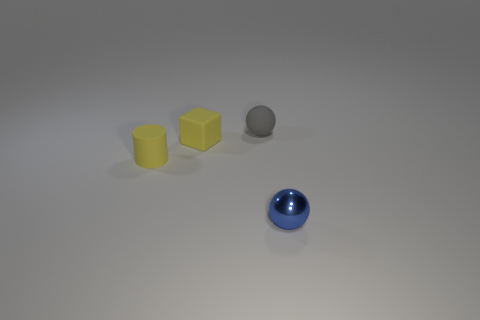Are there any small yellow matte objects to the left of the tiny metal object?
Give a very brief answer. Yes. The metal object that is the same shape as the gray rubber object is what size?
Your answer should be compact. Small. There is a small cylinder; does it have the same color as the ball in front of the rubber sphere?
Keep it short and to the point. No. Do the tiny cylinder and the matte cube have the same color?
Your response must be concise. Yes. Is the number of gray matte cylinders less than the number of yellow blocks?
Offer a terse response. Yes. How many other things are there of the same color as the cylinder?
Provide a short and direct response. 1. How many tiny yellow rubber objects are there?
Make the answer very short. 2. Is the number of gray rubber objects that are to the right of the gray matte thing less than the number of small brown shiny spheres?
Your response must be concise. No. Are the small sphere that is on the right side of the tiny gray sphere and the gray ball made of the same material?
Make the answer very short. No. There is a yellow thing on the right side of the matte cylinder left of the small matte object that is on the right side of the cube; what is its shape?
Offer a very short reply. Cube. 